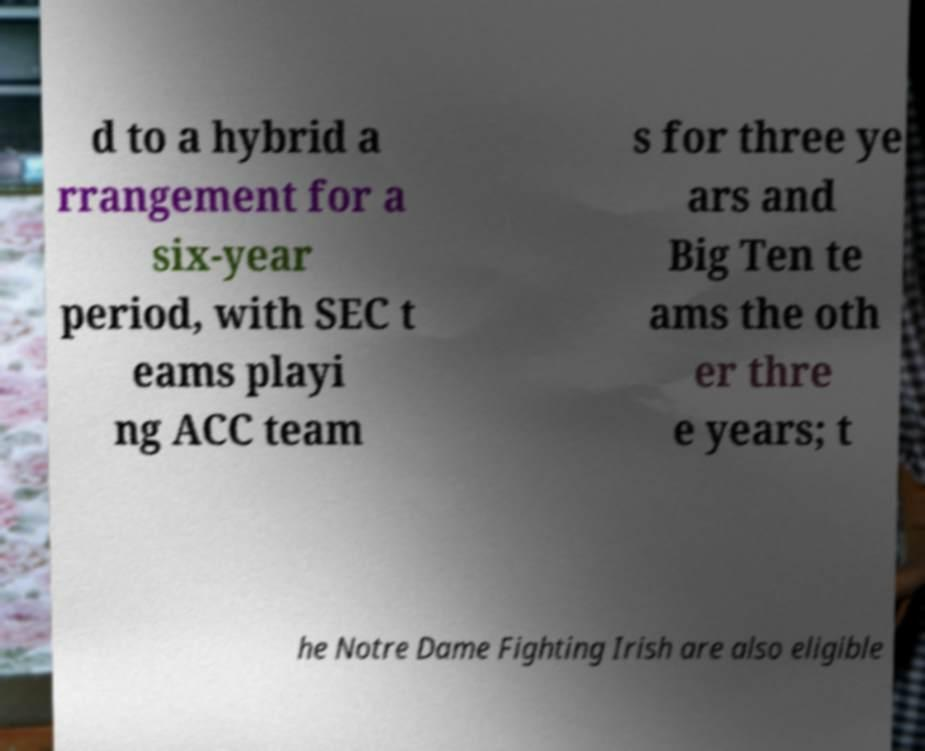There's text embedded in this image that I need extracted. Can you transcribe it verbatim? d to a hybrid a rrangement for a six-year period, with SEC t eams playi ng ACC team s for three ye ars and Big Ten te ams the oth er thre e years; t he Notre Dame Fighting Irish are also eligible 